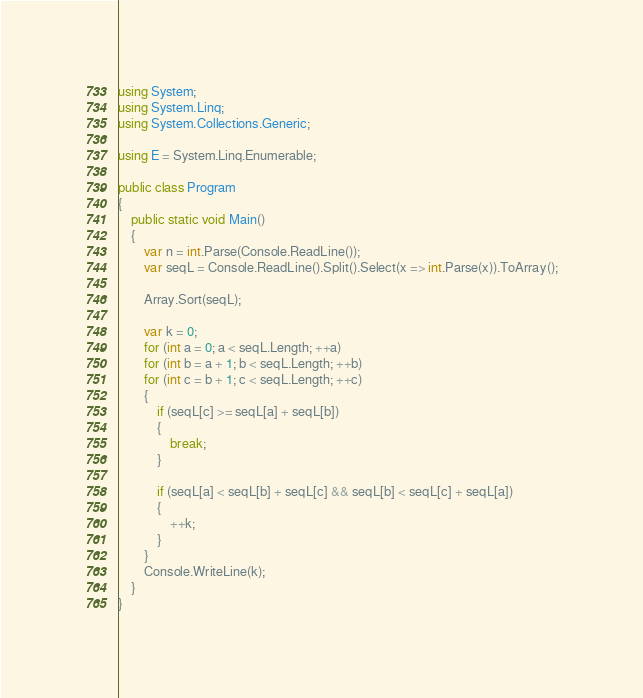Convert code to text. <code><loc_0><loc_0><loc_500><loc_500><_C#_>using System;
using System.Linq;
using System.Collections.Generic;

using E = System.Linq.Enumerable;

public class Program
{
    public static void Main()
    {
        var n = int.Parse(Console.ReadLine());
        var seqL = Console.ReadLine().Split().Select(x => int.Parse(x)).ToArray();

        Array.Sort(seqL);

        var k = 0;
        for (int a = 0; a < seqL.Length; ++a)
        for (int b = a + 1; b < seqL.Length; ++b)
        for (int c = b + 1; c < seqL.Length; ++c)
        {
            if (seqL[c] >= seqL[a] + seqL[b])
            {
                break;
            }
            
            if (seqL[a] < seqL[b] + seqL[c] && seqL[b] < seqL[c] + seqL[a])
            {
                ++k;
            }
        }
        Console.WriteLine(k);
    }
}
</code> 